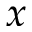<formula> <loc_0><loc_0><loc_500><loc_500>x</formula> 